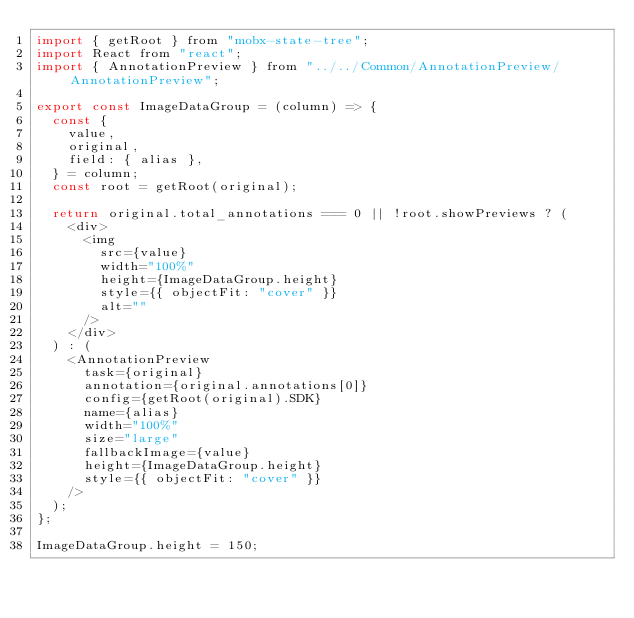<code> <loc_0><loc_0><loc_500><loc_500><_JavaScript_>import { getRoot } from "mobx-state-tree";
import React from "react";
import { AnnotationPreview } from "../../Common/AnnotationPreview/AnnotationPreview";

export const ImageDataGroup = (column) => {
  const {
    value,
    original,
    field: { alias },
  } = column;
  const root = getRoot(original);

  return original.total_annotations === 0 || !root.showPreviews ? (
    <div>
      <img
        src={value}
        width="100%"
        height={ImageDataGroup.height}
        style={{ objectFit: "cover" }}
        alt=""
      />
    </div>
  ) : (
    <AnnotationPreview
      task={original}
      annotation={original.annotations[0]}
      config={getRoot(original).SDK}
      name={alias}
      width="100%"
      size="large"
      fallbackImage={value}
      height={ImageDataGroup.height}
      style={{ objectFit: "cover" }}
    />
  );
};

ImageDataGroup.height = 150;
</code> 